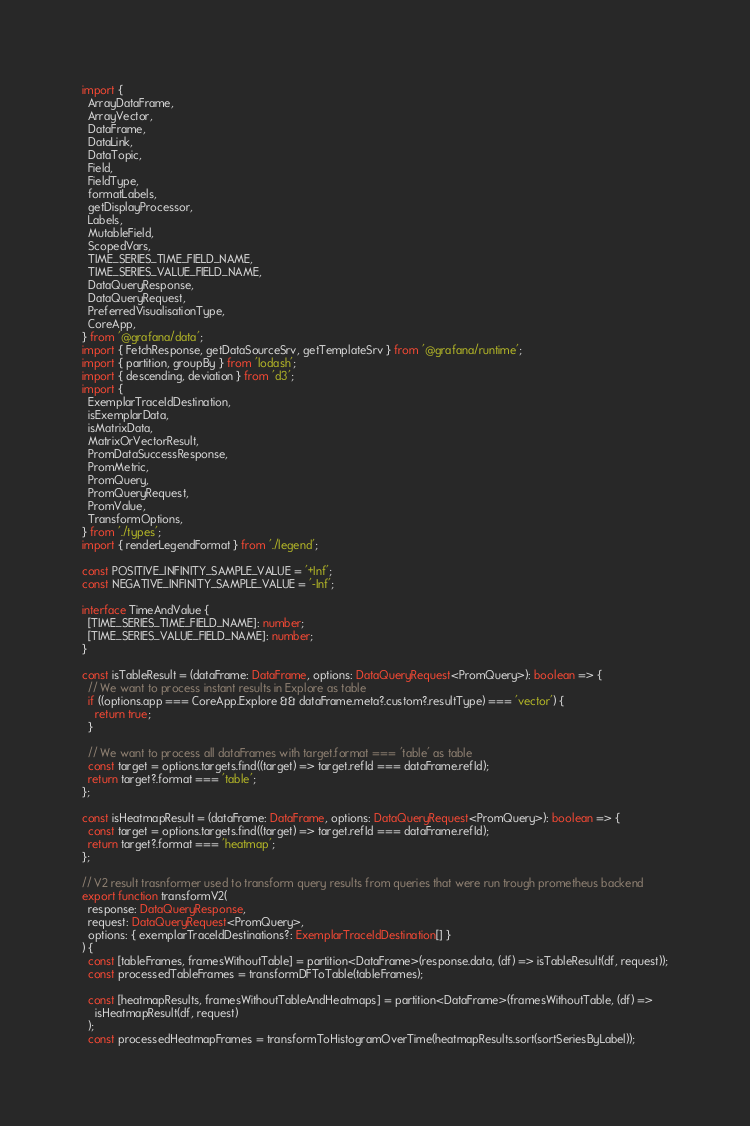<code> <loc_0><loc_0><loc_500><loc_500><_TypeScript_>import {
  ArrayDataFrame,
  ArrayVector,
  DataFrame,
  DataLink,
  DataTopic,
  Field,
  FieldType,
  formatLabels,
  getDisplayProcessor,
  Labels,
  MutableField,
  ScopedVars,
  TIME_SERIES_TIME_FIELD_NAME,
  TIME_SERIES_VALUE_FIELD_NAME,
  DataQueryResponse,
  DataQueryRequest,
  PreferredVisualisationType,
  CoreApp,
} from '@grafana/data';
import { FetchResponse, getDataSourceSrv, getTemplateSrv } from '@grafana/runtime';
import { partition, groupBy } from 'lodash';
import { descending, deviation } from 'd3';
import {
  ExemplarTraceIdDestination,
  isExemplarData,
  isMatrixData,
  MatrixOrVectorResult,
  PromDataSuccessResponse,
  PromMetric,
  PromQuery,
  PromQueryRequest,
  PromValue,
  TransformOptions,
} from './types';
import { renderLegendFormat } from './legend';

const POSITIVE_INFINITY_SAMPLE_VALUE = '+Inf';
const NEGATIVE_INFINITY_SAMPLE_VALUE = '-Inf';

interface TimeAndValue {
  [TIME_SERIES_TIME_FIELD_NAME]: number;
  [TIME_SERIES_VALUE_FIELD_NAME]: number;
}

const isTableResult = (dataFrame: DataFrame, options: DataQueryRequest<PromQuery>): boolean => {
  // We want to process instant results in Explore as table
  if ((options.app === CoreApp.Explore && dataFrame.meta?.custom?.resultType) === 'vector') {
    return true;
  }

  // We want to process all dataFrames with target.format === 'table' as table
  const target = options.targets.find((target) => target.refId === dataFrame.refId);
  return target?.format === 'table';
};

const isHeatmapResult = (dataFrame: DataFrame, options: DataQueryRequest<PromQuery>): boolean => {
  const target = options.targets.find((target) => target.refId === dataFrame.refId);
  return target?.format === 'heatmap';
};

// V2 result trasnformer used to transform query results from queries that were run trough prometheus backend
export function transformV2(
  response: DataQueryResponse,
  request: DataQueryRequest<PromQuery>,
  options: { exemplarTraceIdDestinations?: ExemplarTraceIdDestination[] }
) {
  const [tableFrames, framesWithoutTable] = partition<DataFrame>(response.data, (df) => isTableResult(df, request));
  const processedTableFrames = transformDFToTable(tableFrames);

  const [heatmapResults, framesWithoutTableAndHeatmaps] = partition<DataFrame>(framesWithoutTable, (df) =>
    isHeatmapResult(df, request)
  );
  const processedHeatmapFrames = transformToHistogramOverTime(heatmapResults.sort(sortSeriesByLabel));
</code> 